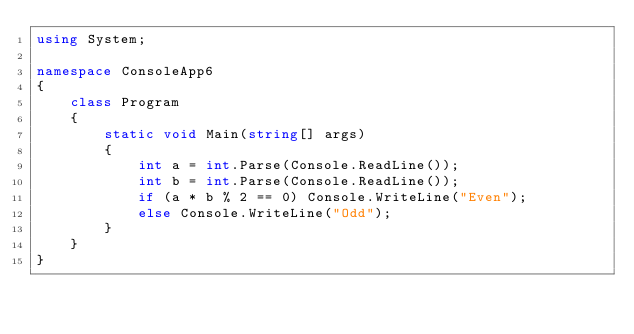Convert code to text. <code><loc_0><loc_0><loc_500><loc_500><_C#_>using System;

namespace ConsoleApp6
{
    class Program
    {
        static void Main(string[] args)
        {
            int a = int.Parse(Console.ReadLine());
            int b = int.Parse(Console.ReadLine());
            if (a * b % 2 == 0) Console.WriteLine("Even");
            else Console.WriteLine("Odd");
        }
    }
}
</code> 